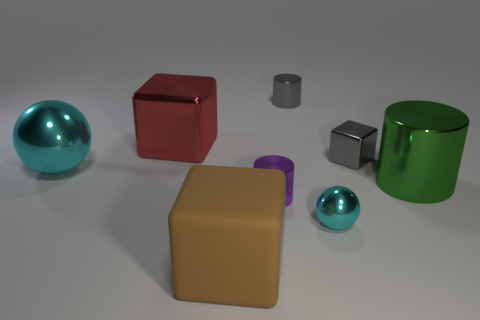There is another big thing that is the same shape as the red thing; what is it made of? Assuming the question refers to the other large cubic object, which appears to be the gold-colored box, it's not possible to ascertain the exact material from a visual inspection of an image alone. However, it looks metallic, judging by its reflective surface and the way it casts and reflects light, similar to the red cube, which may indicate a material like polished metal or a metal alloy. 